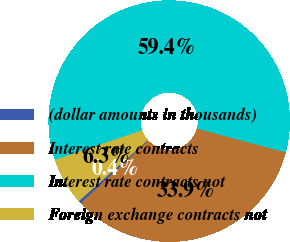Convert chart to OTSL. <chart><loc_0><loc_0><loc_500><loc_500><pie_chart><fcel>(dollar amounts in thousands)<fcel>Interest rate contracts<fcel>Interest rate contracts not<fcel>Foreign exchange contracts not<nl><fcel>0.4%<fcel>33.91%<fcel>59.38%<fcel>6.3%<nl></chart> 